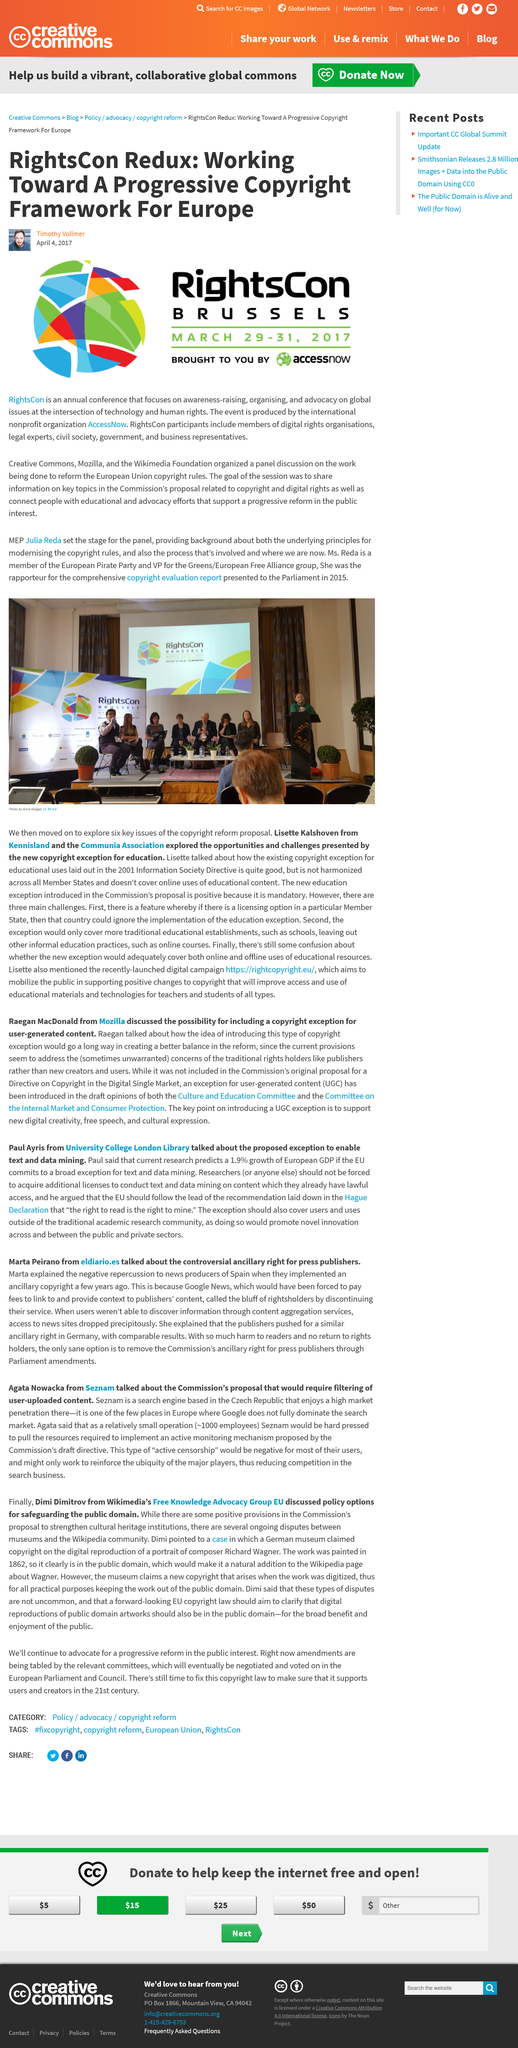Specify some key components in this picture. The RightsCon conference is held annually. The RightsCon conference in 2017 took place on March 29, 30, and 31. The 2017 RightsCon was held in Brussels. 